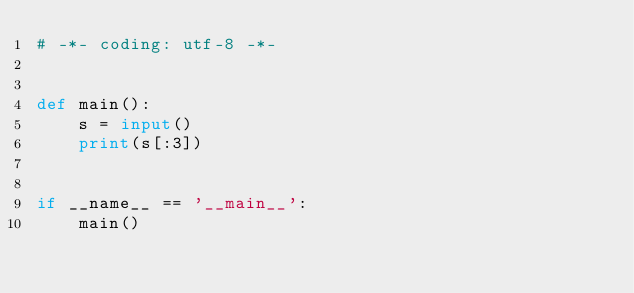<code> <loc_0><loc_0><loc_500><loc_500><_Python_># -*- coding: utf-8 -*-


def main():
    s = input()
    print(s[:3])


if __name__ == '__main__':
    main()
</code> 